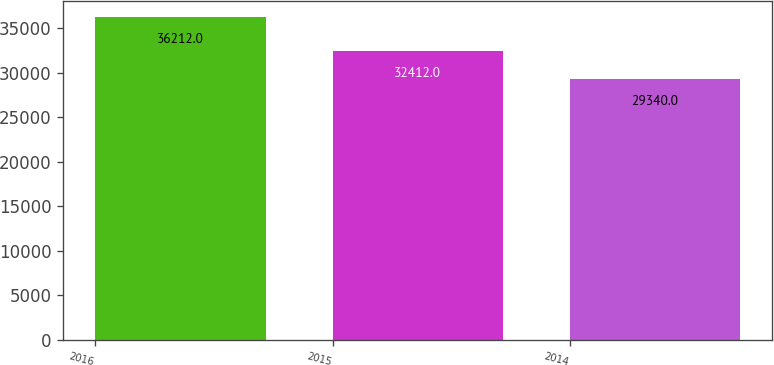Convert chart to OTSL. <chart><loc_0><loc_0><loc_500><loc_500><bar_chart><fcel>2016<fcel>2015<fcel>2014<nl><fcel>36212<fcel>32412<fcel>29340<nl></chart> 